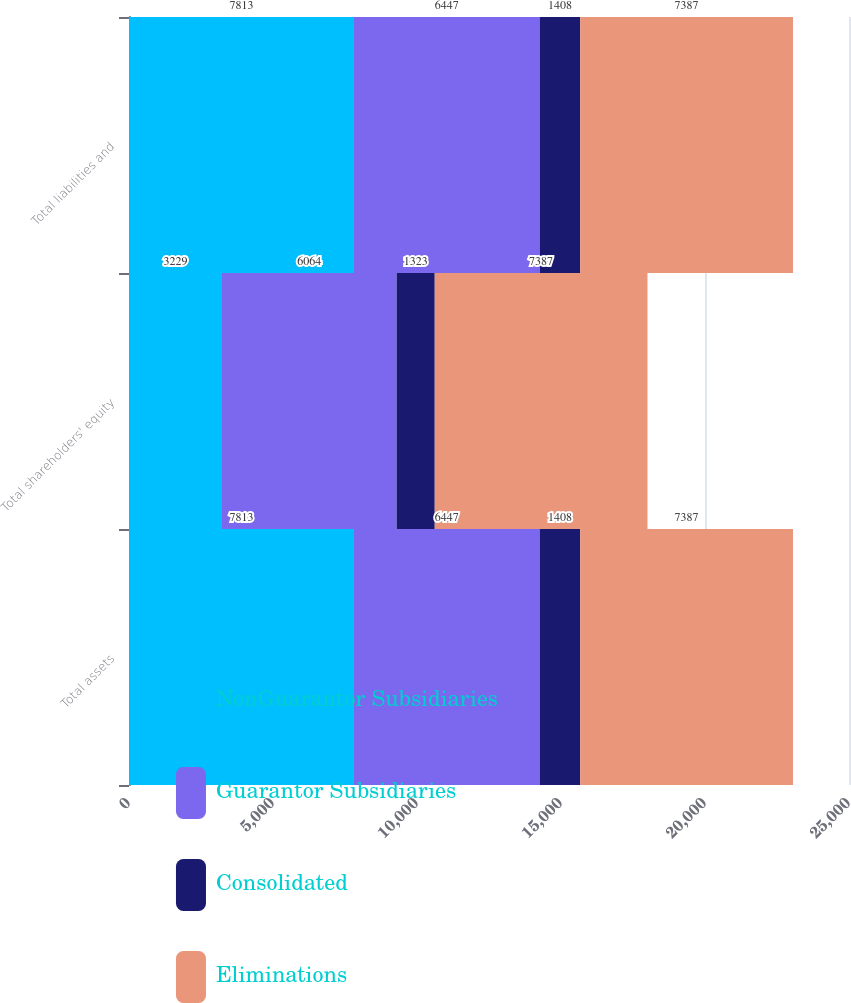Convert chart. <chart><loc_0><loc_0><loc_500><loc_500><stacked_bar_chart><ecel><fcel>Total assets<fcel>Total shareholders' equity<fcel>Total liabilities and<nl><fcel>NonGuarantor Subsidiaries<fcel>7813<fcel>3229<fcel>7813<nl><fcel>Guarantor Subsidiaries<fcel>6447<fcel>6064<fcel>6447<nl><fcel>Consolidated<fcel>1408<fcel>1323<fcel>1408<nl><fcel>Eliminations<fcel>7387<fcel>7387<fcel>7387<nl></chart> 